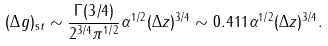Convert formula to latex. <formula><loc_0><loc_0><loc_500><loc_500>( \Delta g ) _ { \mathrm s t } \sim \frac { \Gamma ( 3 / 4 ) } { 2 ^ { 3 / 4 } \pi ^ { 1 / 2 } } \alpha ^ { 1 / 2 } ( \Delta z ) ^ { 3 / 4 } \sim 0 . 4 1 1 \alpha ^ { 1 / 2 } ( \Delta z ) ^ { 3 / 4 } .</formula> 